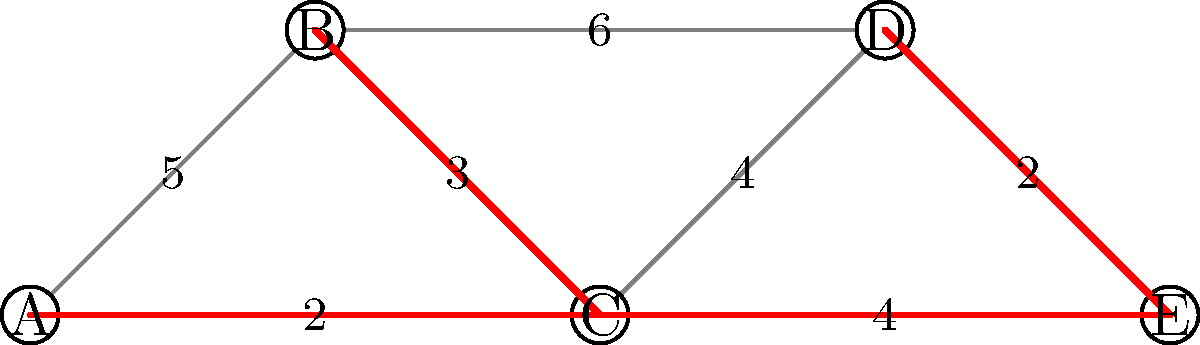During a merger between two tech companies, you are tasked with optimizing the integration of their IT infrastructure. The graph represents the potential connections between different systems (nodes A-E) and the associated costs (edge weights). What is the total cost of implementing the minimum spanning tree for this integration, and which connections should be established? To solve this problem, we'll use Kruskal's algorithm to find the minimum spanning tree (MST):

1. Sort all edges by weight in ascending order:
   (A,C): 2
   (D,E): 2
   (B,C): 3
   (C,D): 4
   (C,E): 4
   (A,B): 5
   (B,D): 6

2. Start with an empty MST and add edges in order, skipping those that would create a cycle:
   - Add (A,C): 2
   - Add (D,E): 2
   - Add (B,C): 3
   - Skip (C,D) and (C,E) as they would create cycles
   - Skip (A,B) and (B,D) as they would create cycles

3. The resulting MST consists of edges:
   (A,C), (D,E), (B,C)

4. Calculate the total cost:
   2 + 2 + 3 = 7

Therefore, the minimum spanning tree has a total cost of 7, and the connections to be established are:
A-C, D-E, and B-C.
Answer: Total cost: 7; Connections: A-C, D-E, B-C 